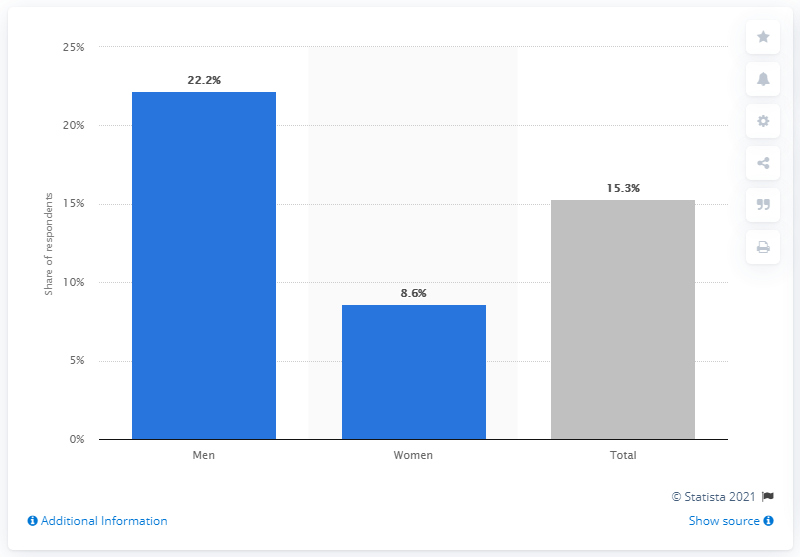Can you tell me more about the source of this data? The source of this data, as indicated in the image, is Statista. The data is from the year 2021. Statista is a reputable statistics portal that compiles data from various surveys and reports. 